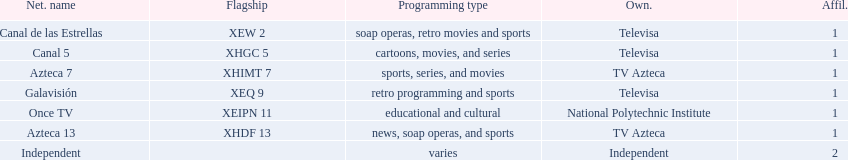How many affiliates does galavision have? 1. Could you parse the entire table as a dict? {'header': ['Net. name', 'Flagship', 'Programming type', 'Own.', 'Affil.'], 'rows': [['Canal de las Estrellas', 'XEW 2', 'soap operas, retro movies and sports', 'Televisa', '1'], ['Canal 5', 'XHGC 5', 'cartoons, movies, and series', 'Televisa', '1'], ['Azteca 7', 'XHIMT 7', 'sports, series, and movies', 'TV Azteca', '1'], ['Galavisión', 'XEQ 9', 'retro programming and sports', 'Televisa', '1'], ['Once TV', 'XEIPN 11', 'educational and cultural', 'National Polytechnic Institute', '1'], ['Azteca 13', 'XHDF 13', 'news, soap operas, and sports', 'TV Azteca', '1'], ['Independent', '', 'varies', 'Independent', '2']]} 